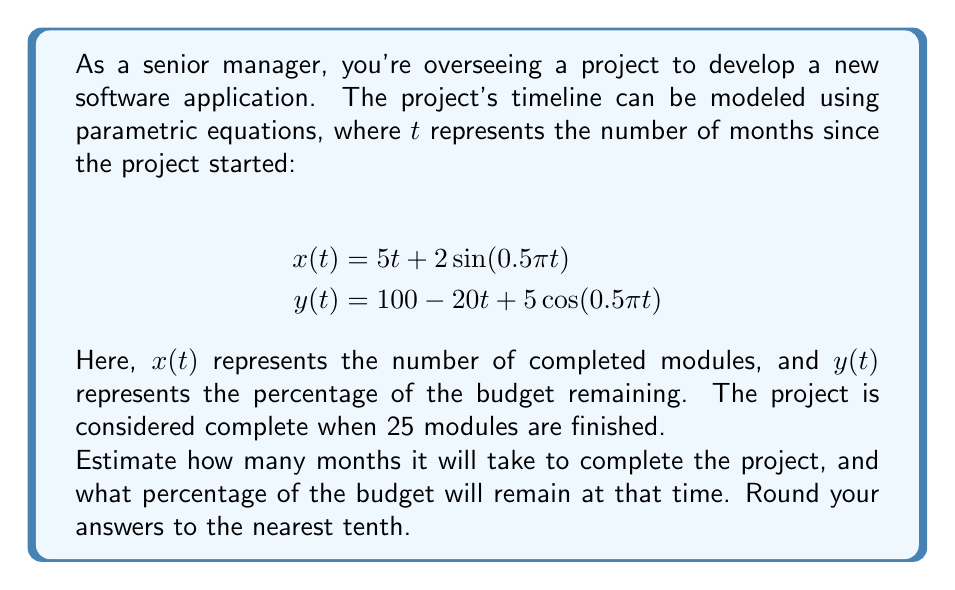Help me with this question. To solve this problem, we need to follow these steps:

1) We need to find the value of $t$ when $x(t) = 25$ (completed modules).

2) We can't solve this equation algebraically due to the sine function, so we'll use a numerical method like the bisection method or trial and error.

3) Let's try some values:

   At $t = 4$: $x(4) = 5(4) + 2\sin(0.5\pi(4)) = 20 + 0 = 20$
   At $t = 5$: $x(5) = 5(5) + 2\sin(0.5\pi(5)) = 25 - 2 = 23$
   At $t = 5.2$: $x(5.2) \approx 5(5.2) + 2\sin(0.5\pi(5.2)) \approx 26 - 1.24 = 24.76$
   At $t = 5.3$: $x(5.3) \approx 5(5.3) + 2\sin(0.5\pi(5.3)) \approx 26.5 - 0.63 = 25.87$

4) By interpolation, we can estimate that 25 modules are completed at approximately $t = 5.25$ months.

5) Now we need to calculate $y(5.25)$ to find the remaining budget percentage:

   $y(5.25) = 100 - 20(5.25) + 5\cos(0.5\pi(5.25))$
            $\approx 100 - 105 + 5(-0.16)$
            $\approx -5.8$

6) However, budget percentage can't be negative in reality. This suggests that the budget will be depleted before the project is completed.

7) To find when the budget reaches 0%, we need to solve $y(t) = 0$:

   $100 - 20t + 5\cos(0.5\pi t) = 0$

8) Again, we'll use trial and error:

   At $t = 5$: $y(5) = 100 - 100 - 5 = -5$
   At $t = 4.9$: $y(4.9) \approx 100 - 98 - 3.2 = -1.2$
   At $t = 4.8$: $y(4.8) \approx 100 - 96 + 0 = 4$

9) By interpolation, we can estimate that the budget reaches 0% at approximately $t = 4.85$ months.
Answer: The project will run out of budget after approximately 4.9 months, with only about 23.7 modules completed. The project cannot be completed within the given budget and timeline. 